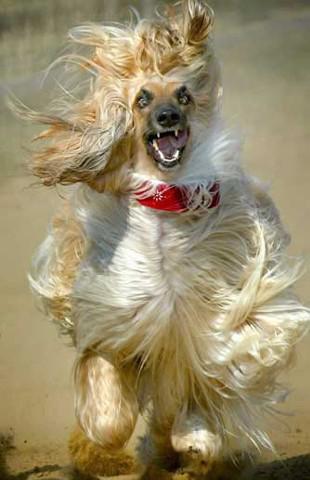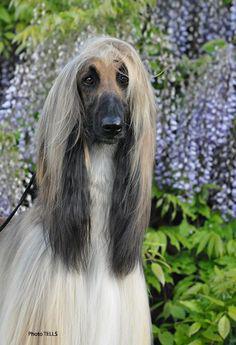The first image is the image on the left, the second image is the image on the right. Examine the images to the left and right. Is the description "There are at least 2 dogs lying on the ground and facing right." accurate? Answer yes or no. No. 